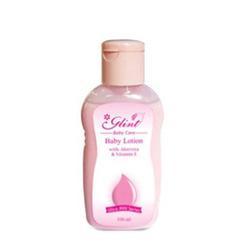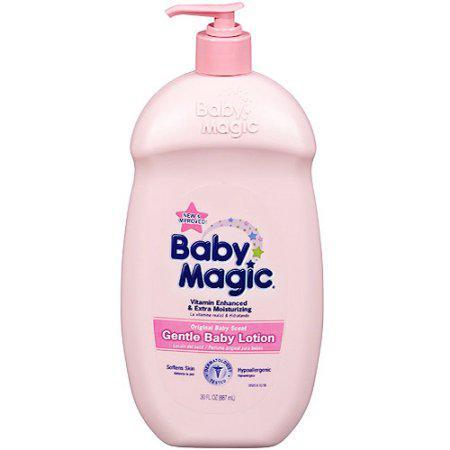The first image is the image on the left, the second image is the image on the right. For the images shown, is this caption "there is a single bottle with a pump top" true? Answer yes or no. Yes. The first image is the image on the left, the second image is the image on the right. Considering the images on both sides, is "There are three items." valid? Answer yes or no. No. 